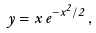<formula> <loc_0><loc_0><loc_500><loc_500>y = x \, e ^ { - x ^ { 2 } / 2 } \, ,</formula> 